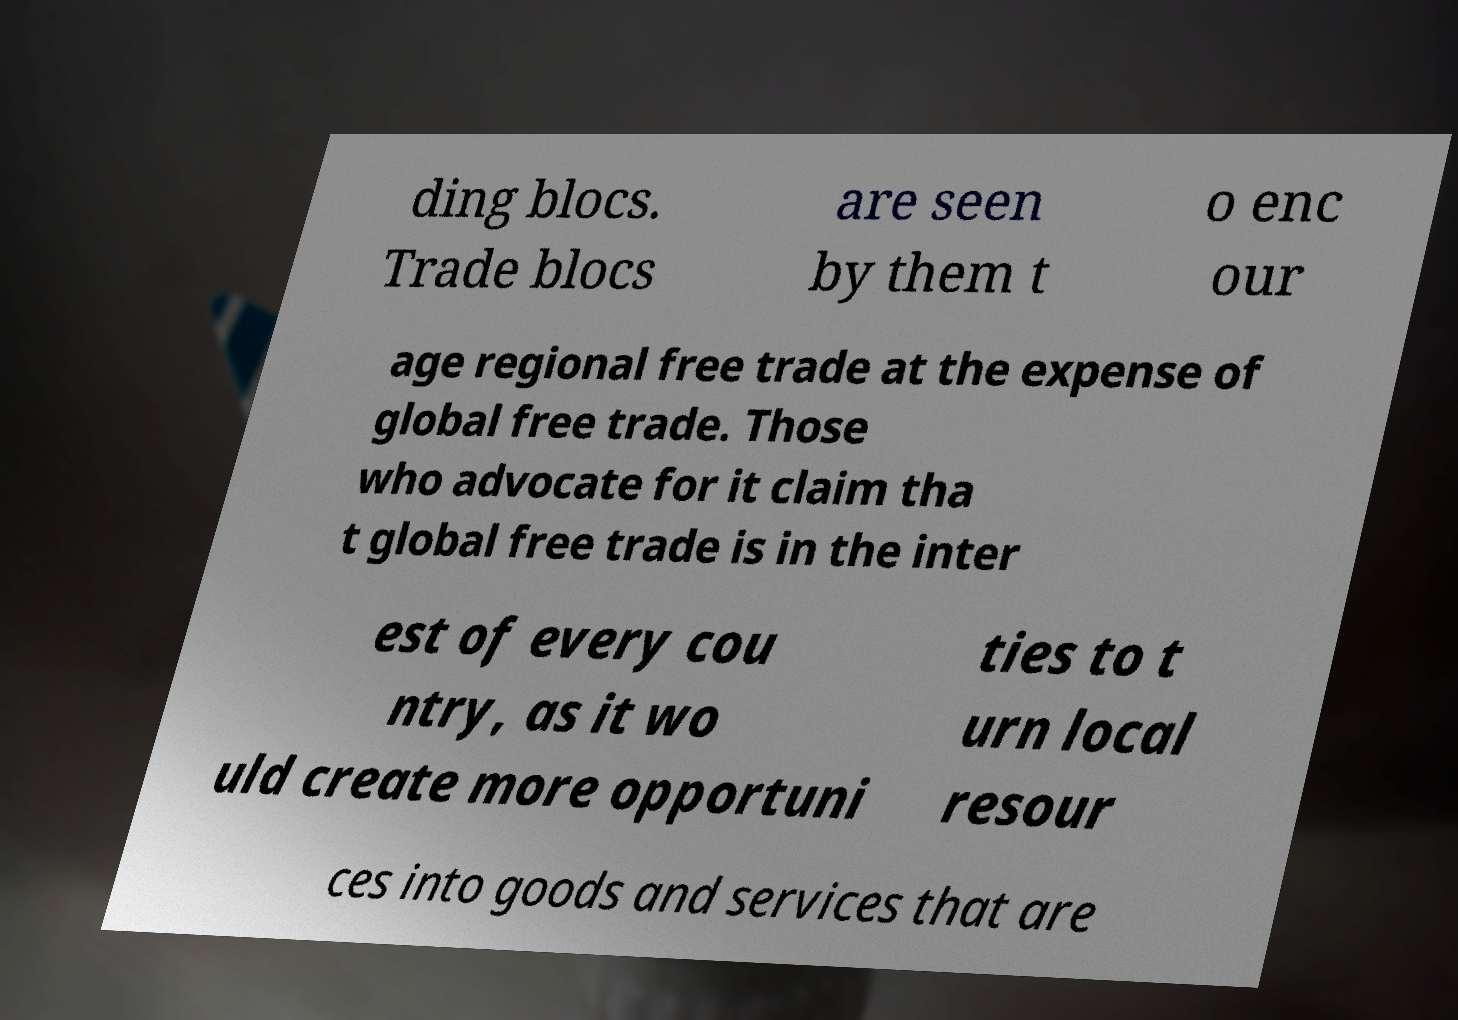Please identify and transcribe the text found in this image. ding blocs. Trade blocs are seen by them t o enc our age regional free trade at the expense of global free trade. Those who advocate for it claim tha t global free trade is in the inter est of every cou ntry, as it wo uld create more opportuni ties to t urn local resour ces into goods and services that are 